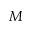<formula> <loc_0><loc_0><loc_500><loc_500>M</formula> 